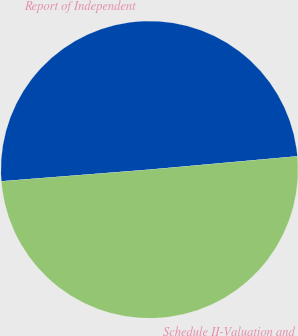Convert chart to OTSL. <chart><loc_0><loc_0><loc_500><loc_500><pie_chart><fcel>Report of Independent<fcel>Schedule II-Valuation and<nl><fcel>49.82%<fcel>50.18%<nl></chart> 